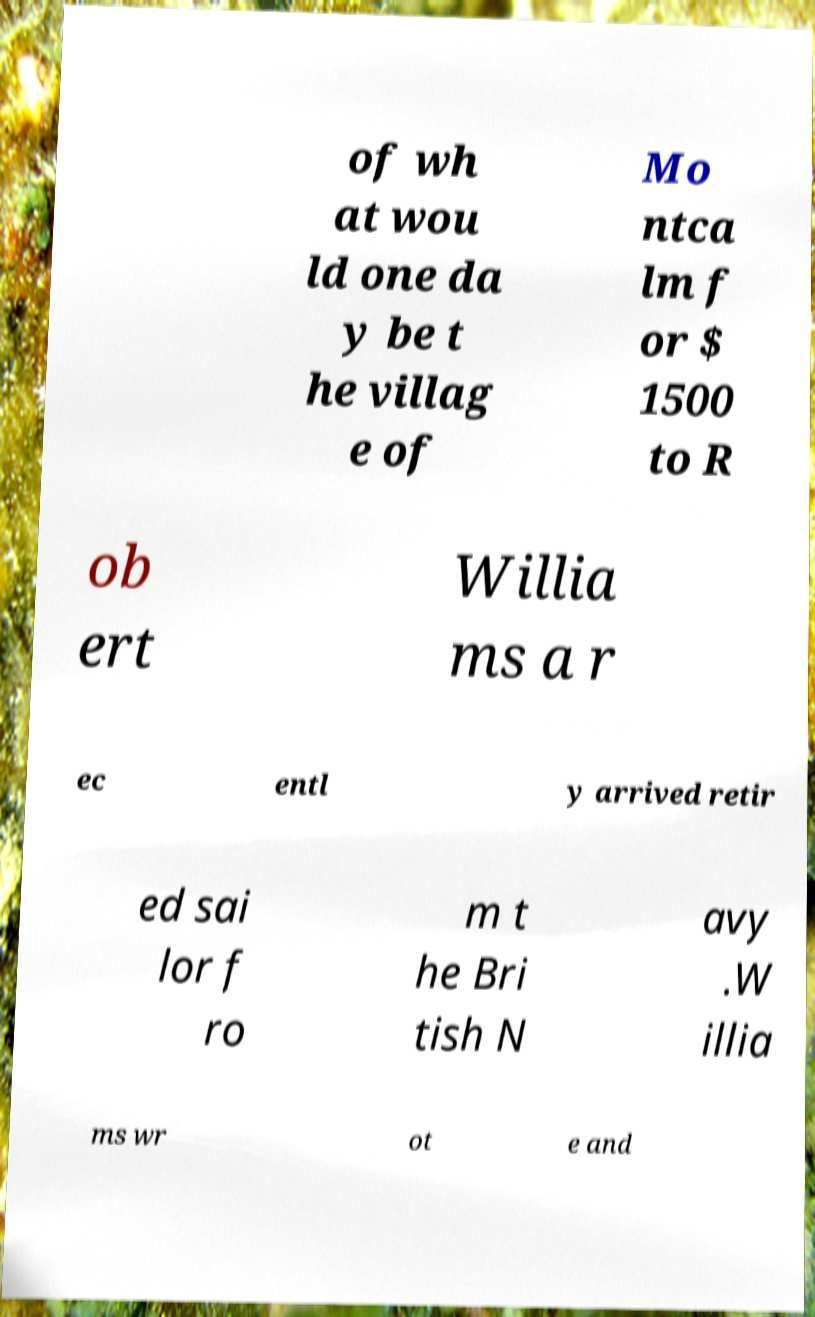There's text embedded in this image that I need extracted. Can you transcribe it verbatim? of wh at wou ld one da y be t he villag e of Mo ntca lm f or $ 1500 to R ob ert Willia ms a r ec entl y arrived retir ed sai lor f ro m t he Bri tish N avy .W illia ms wr ot e and 